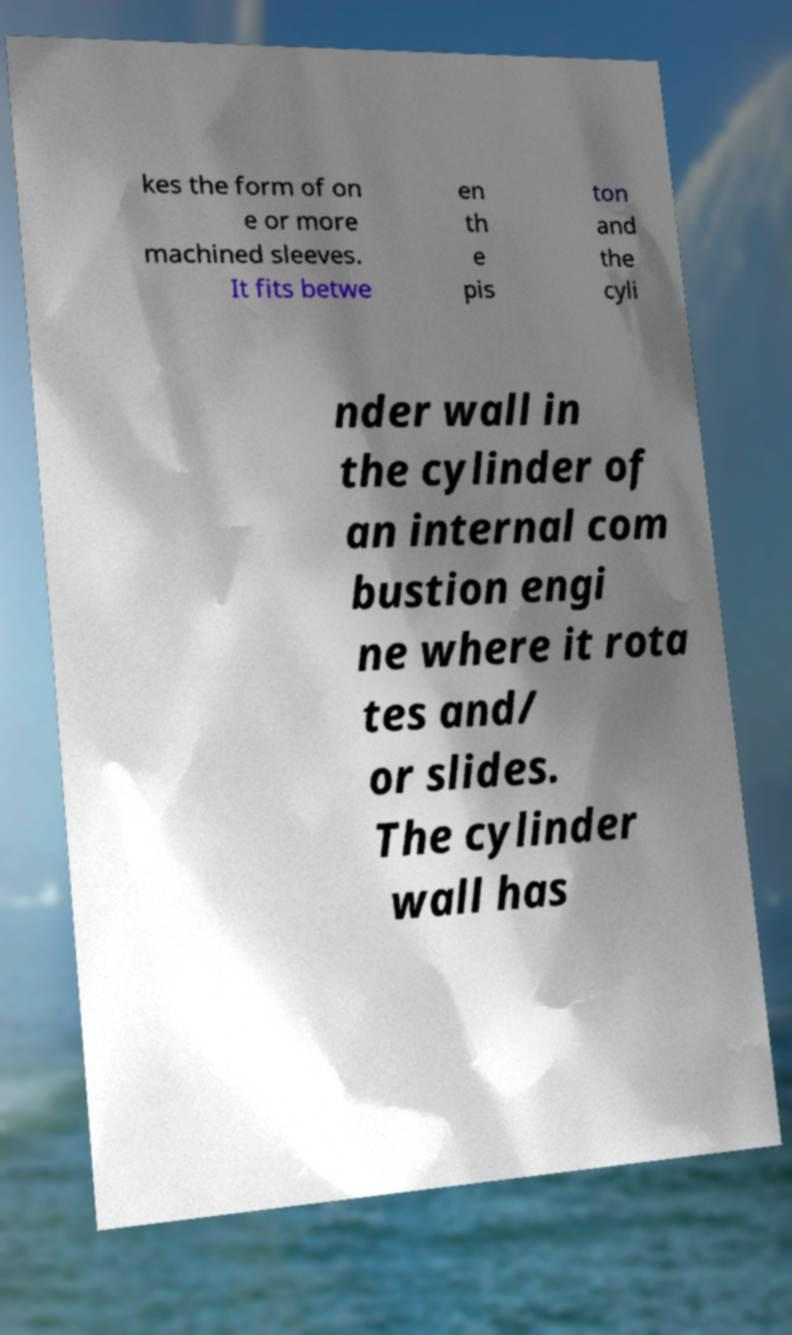Can you read and provide the text displayed in the image?This photo seems to have some interesting text. Can you extract and type it out for me? kes the form of on e or more machined sleeves. It fits betwe en th e pis ton and the cyli nder wall in the cylinder of an internal com bustion engi ne where it rota tes and/ or slides. The cylinder wall has 